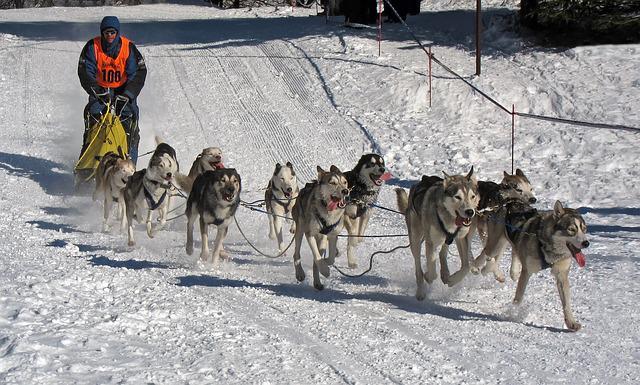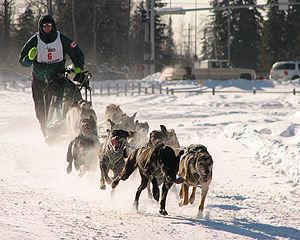The first image is the image on the left, the second image is the image on the right. Analyze the images presented: Is the assertion "One image features a sled driver wearing glasses and a white race vest." valid? Answer yes or no. Yes. The first image is the image on the left, the second image is the image on the right. Analyze the images presented: Is the assertion "Only one person can be seen with each of two teams of dogs." valid? Answer yes or no. Yes. 